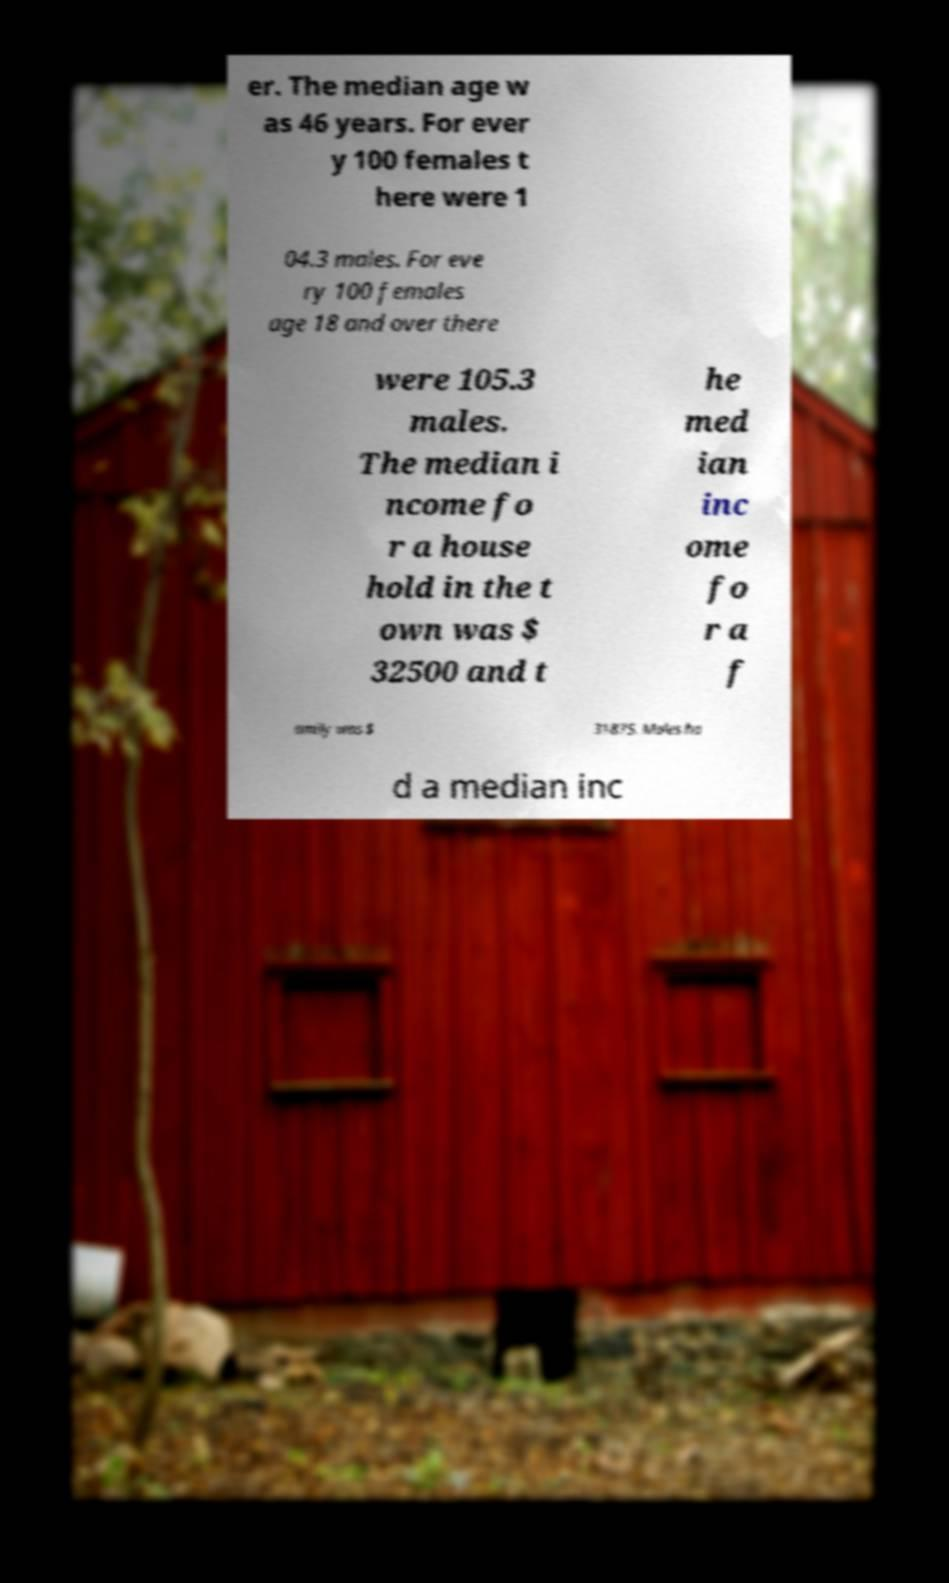Please identify and transcribe the text found in this image. er. The median age w as 46 years. For ever y 100 females t here were 1 04.3 males. For eve ry 100 females age 18 and over there were 105.3 males. The median i ncome fo r a house hold in the t own was $ 32500 and t he med ian inc ome fo r a f amily was $ 31875. Males ha d a median inc 